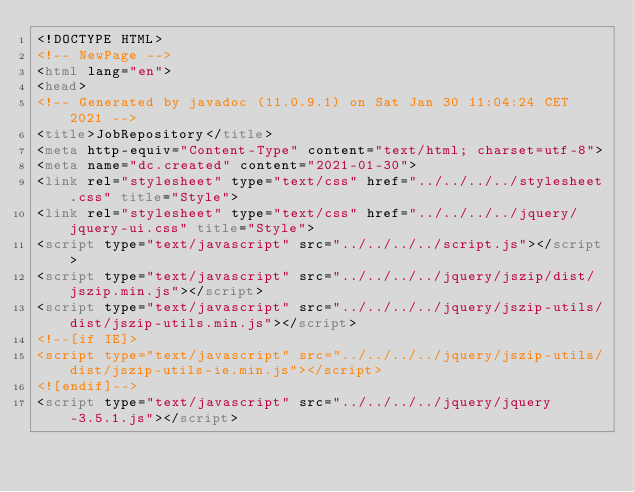<code> <loc_0><loc_0><loc_500><loc_500><_HTML_><!DOCTYPE HTML>
<!-- NewPage -->
<html lang="en">
<head>
<!-- Generated by javadoc (11.0.9.1) on Sat Jan 30 11:04:24 CET 2021 -->
<title>JobRepository</title>
<meta http-equiv="Content-Type" content="text/html; charset=utf-8">
<meta name="dc.created" content="2021-01-30">
<link rel="stylesheet" type="text/css" href="../../../../stylesheet.css" title="Style">
<link rel="stylesheet" type="text/css" href="../../../../jquery/jquery-ui.css" title="Style">
<script type="text/javascript" src="../../../../script.js"></script>
<script type="text/javascript" src="../../../../jquery/jszip/dist/jszip.min.js"></script>
<script type="text/javascript" src="../../../../jquery/jszip-utils/dist/jszip-utils.min.js"></script>
<!--[if IE]>
<script type="text/javascript" src="../../../../jquery/jszip-utils/dist/jszip-utils-ie.min.js"></script>
<![endif]-->
<script type="text/javascript" src="../../../../jquery/jquery-3.5.1.js"></script></code> 